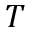<formula> <loc_0><loc_0><loc_500><loc_500>T</formula> 